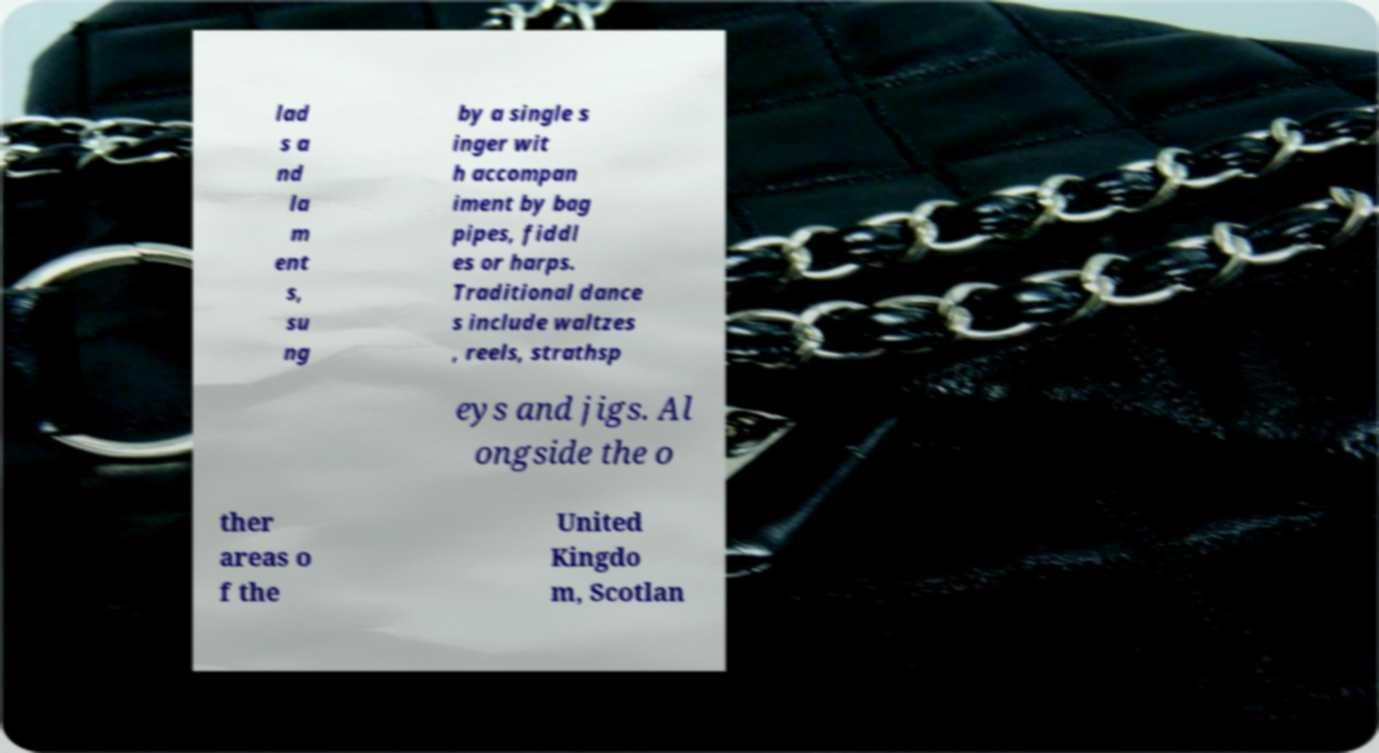Could you extract and type out the text from this image? lad s a nd la m ent s, su ng by a single s inger wit h accompan iment by bag pipes, fiddl es or harps. Traditional dance s include waltzes , reels, strathsp eys and jigs. Al ongside the o ther areas o f the United Kingdo m, Scotlan 